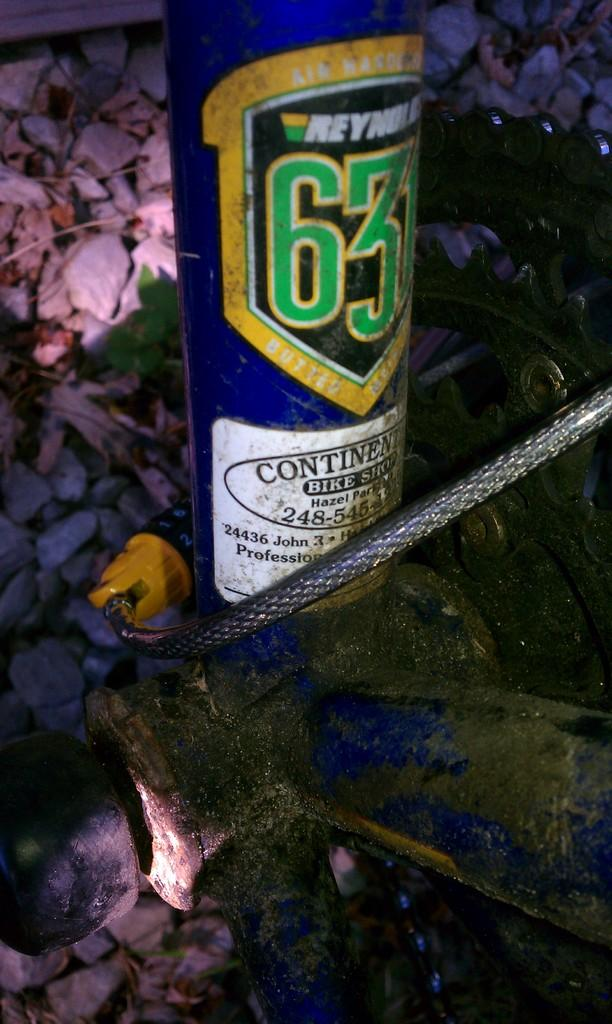Provide a one-sentence caption for the provided image. Bike lock wrapped around a can from Continental Bike Shop. 